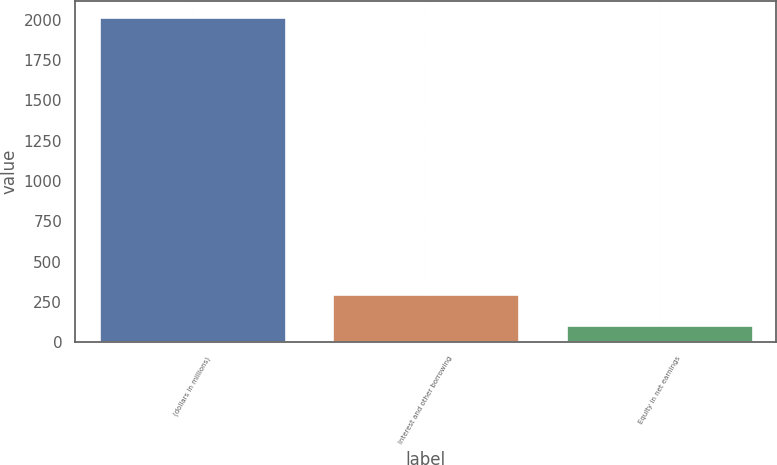<chart> <loc_0><loc_0><loc_500><loc_500><bar_chart><fcel>(dollars in millions)<fcel>Interest and other borrowing<fcel>Equity in net earnings<nl><fcel>2016<fcel>300.78<fcel>110.2<nl></chart> 